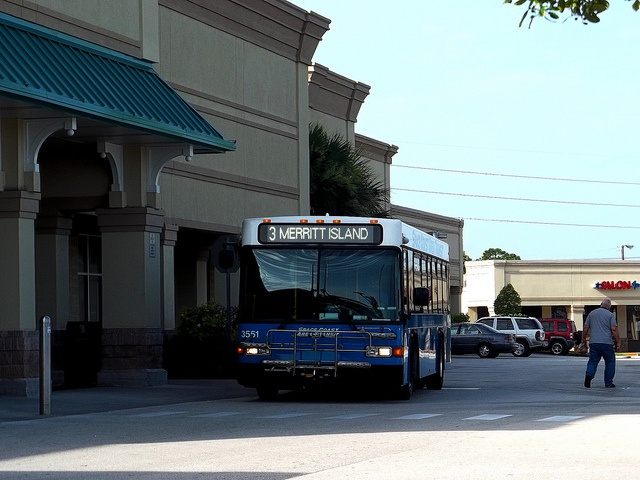Describe the objects in this image and their specific colors. I can see bus in black, navy, gray, and blue tones, potted plant in black and darkgreen tones, people in black, gray, darkblue, and navy tones, car in black, navy, gray, and darkblue tones, and car in black, gray, and darkgray tones in this image. 